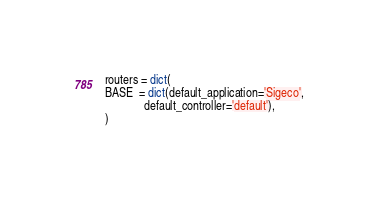<code> <loc_0><loc_0><loc_500><loc_500><_Python_>
routers = dict(
BASE  = dict(default_application='Sigeco',
             default_controller='default'),
)
</code> 